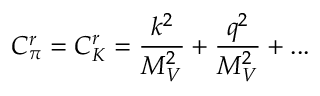Convert formula to latex. <formula><loc_0><loc_0><loc_500><loc_500>C _ { \pi } ^ { r } = C _ { K } ^ { r } = { \frac { k ^ { 2 } } { M _ { V } ^ { 2 } } } + { \frac { q ^ { 2 } } { M _ { V } ^ { 2 } } } + \dots</formula> 